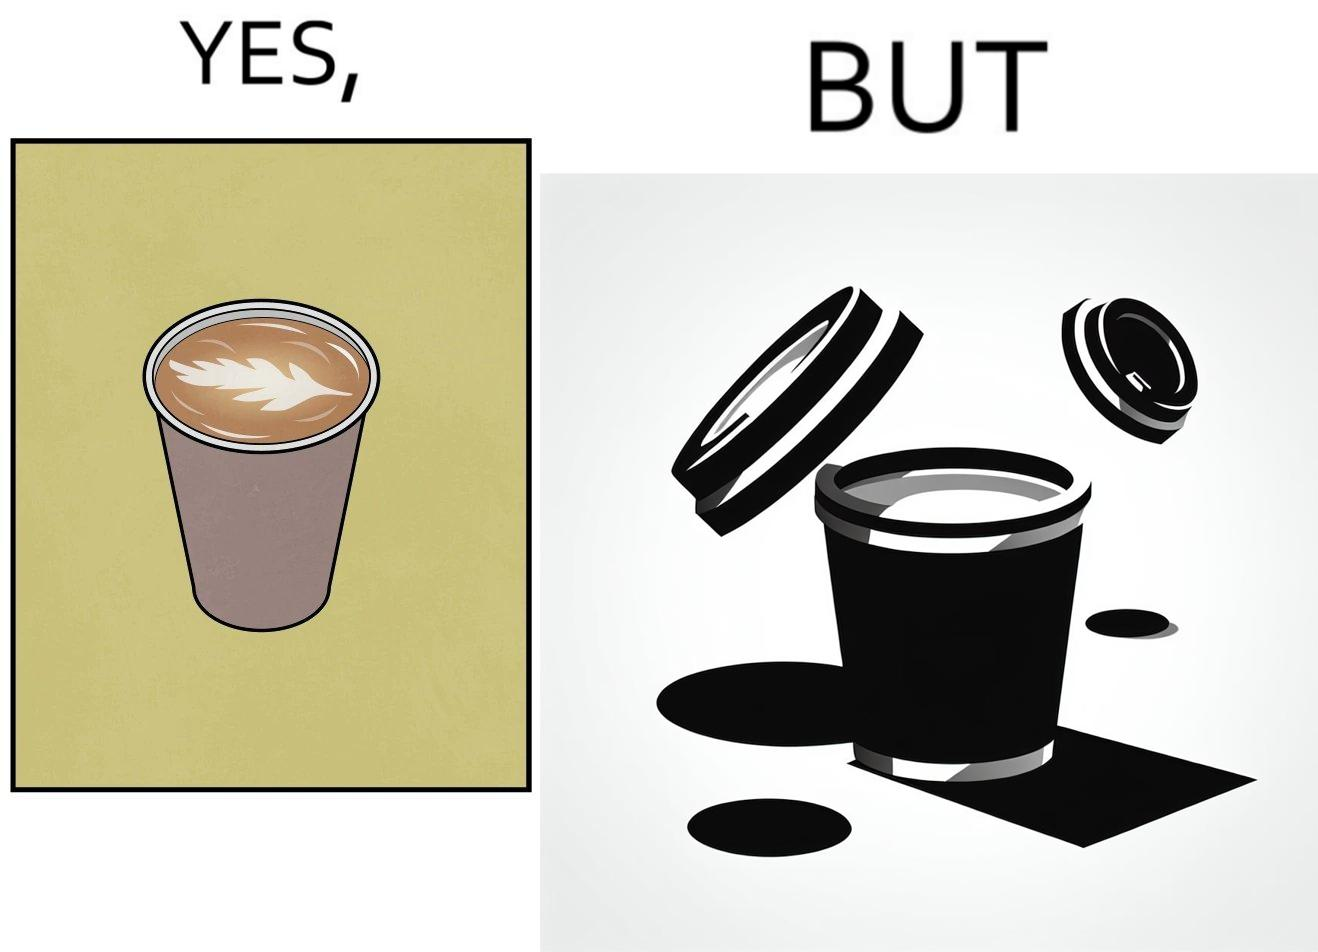Would you classify this image as satirical? Yes, this image is satirical. 